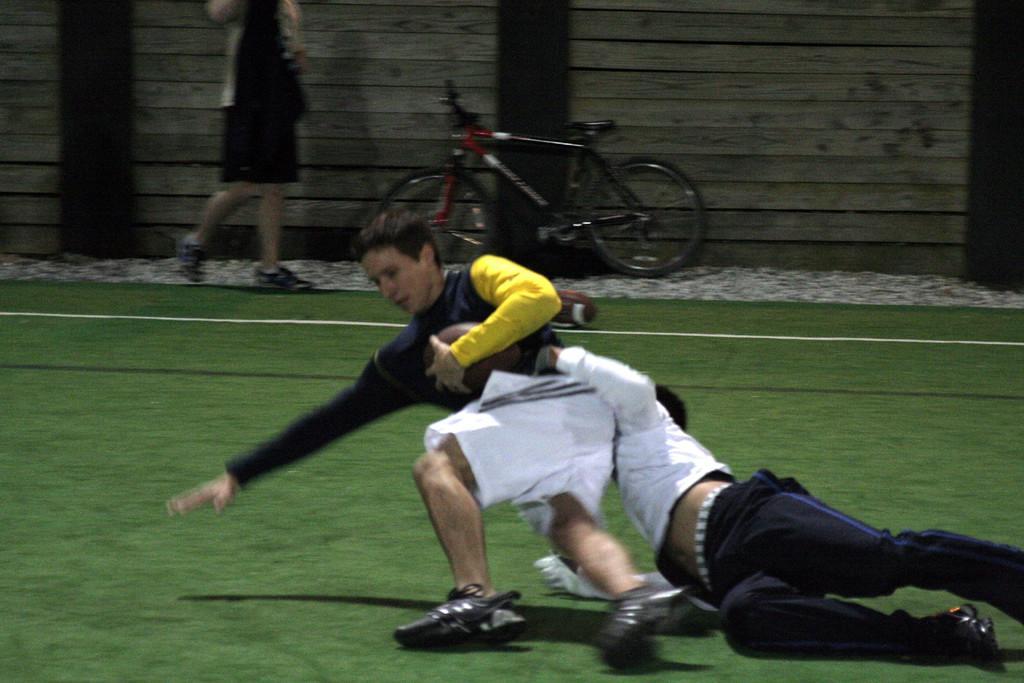Describe this image in one or two sentences. In the image there is a person laying on the grass field holding another person while running along with rugby ball and behind there is a person walking in front of the wall with a cycle in front of him. 